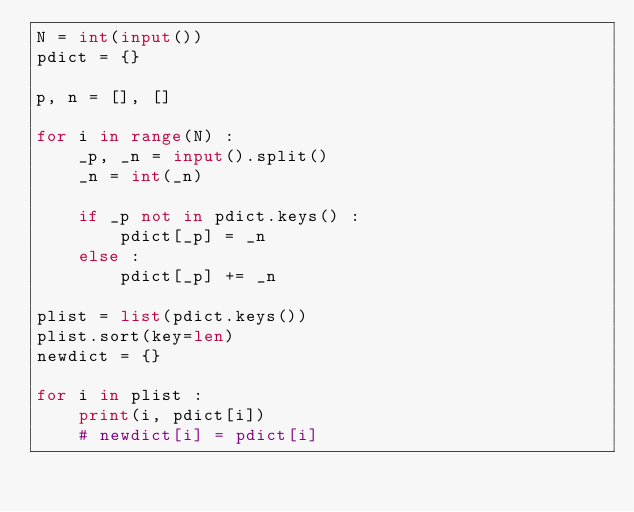Convert code to text. <code><loc_0><loc_0><loc_500><loc_500><_Python_>N = int(input())
pdict = {}

p, n = [], []

for i in range(N) :
    _p, _n = input().split()
    _n = int(_n)
    
    if _p not in pdict.keys() :
        pdict[_p] = _n
    else :
        pdict[_p] += _n
        
plist = list(pdict.keys())
plist.sort(key=len)
newdict = {}

for i in plist :
    print(i, pdict[i])
    # newdict[i] = pdict[i]
</code> 